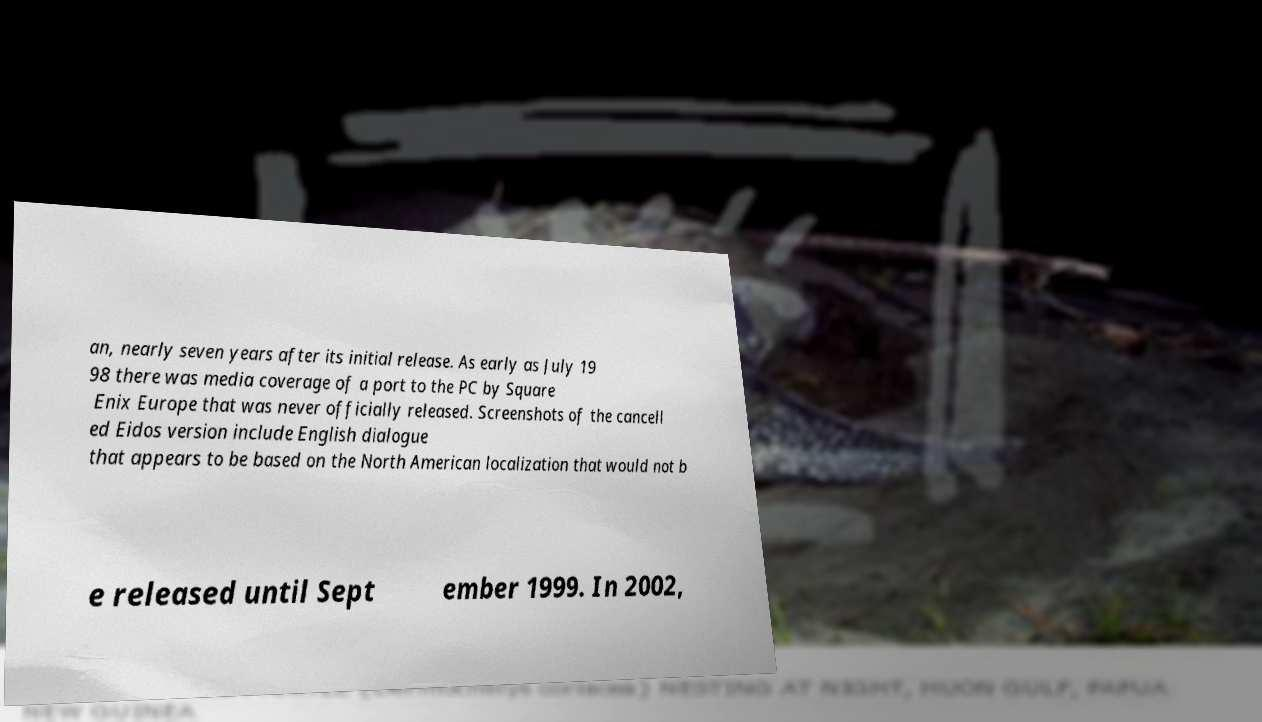Can you accurately transcribe the text from the provided image for me? an, nearly seven years after its initial release. As early as July 19 98 there was media coverage of a port to the PC by Square Enix Europe that was never officially released. Screenshots of the cancell ed Eidos version include English dialogue that appears to be based on the North American localization that would not b e released until Sept ember 1999. In 2002, 